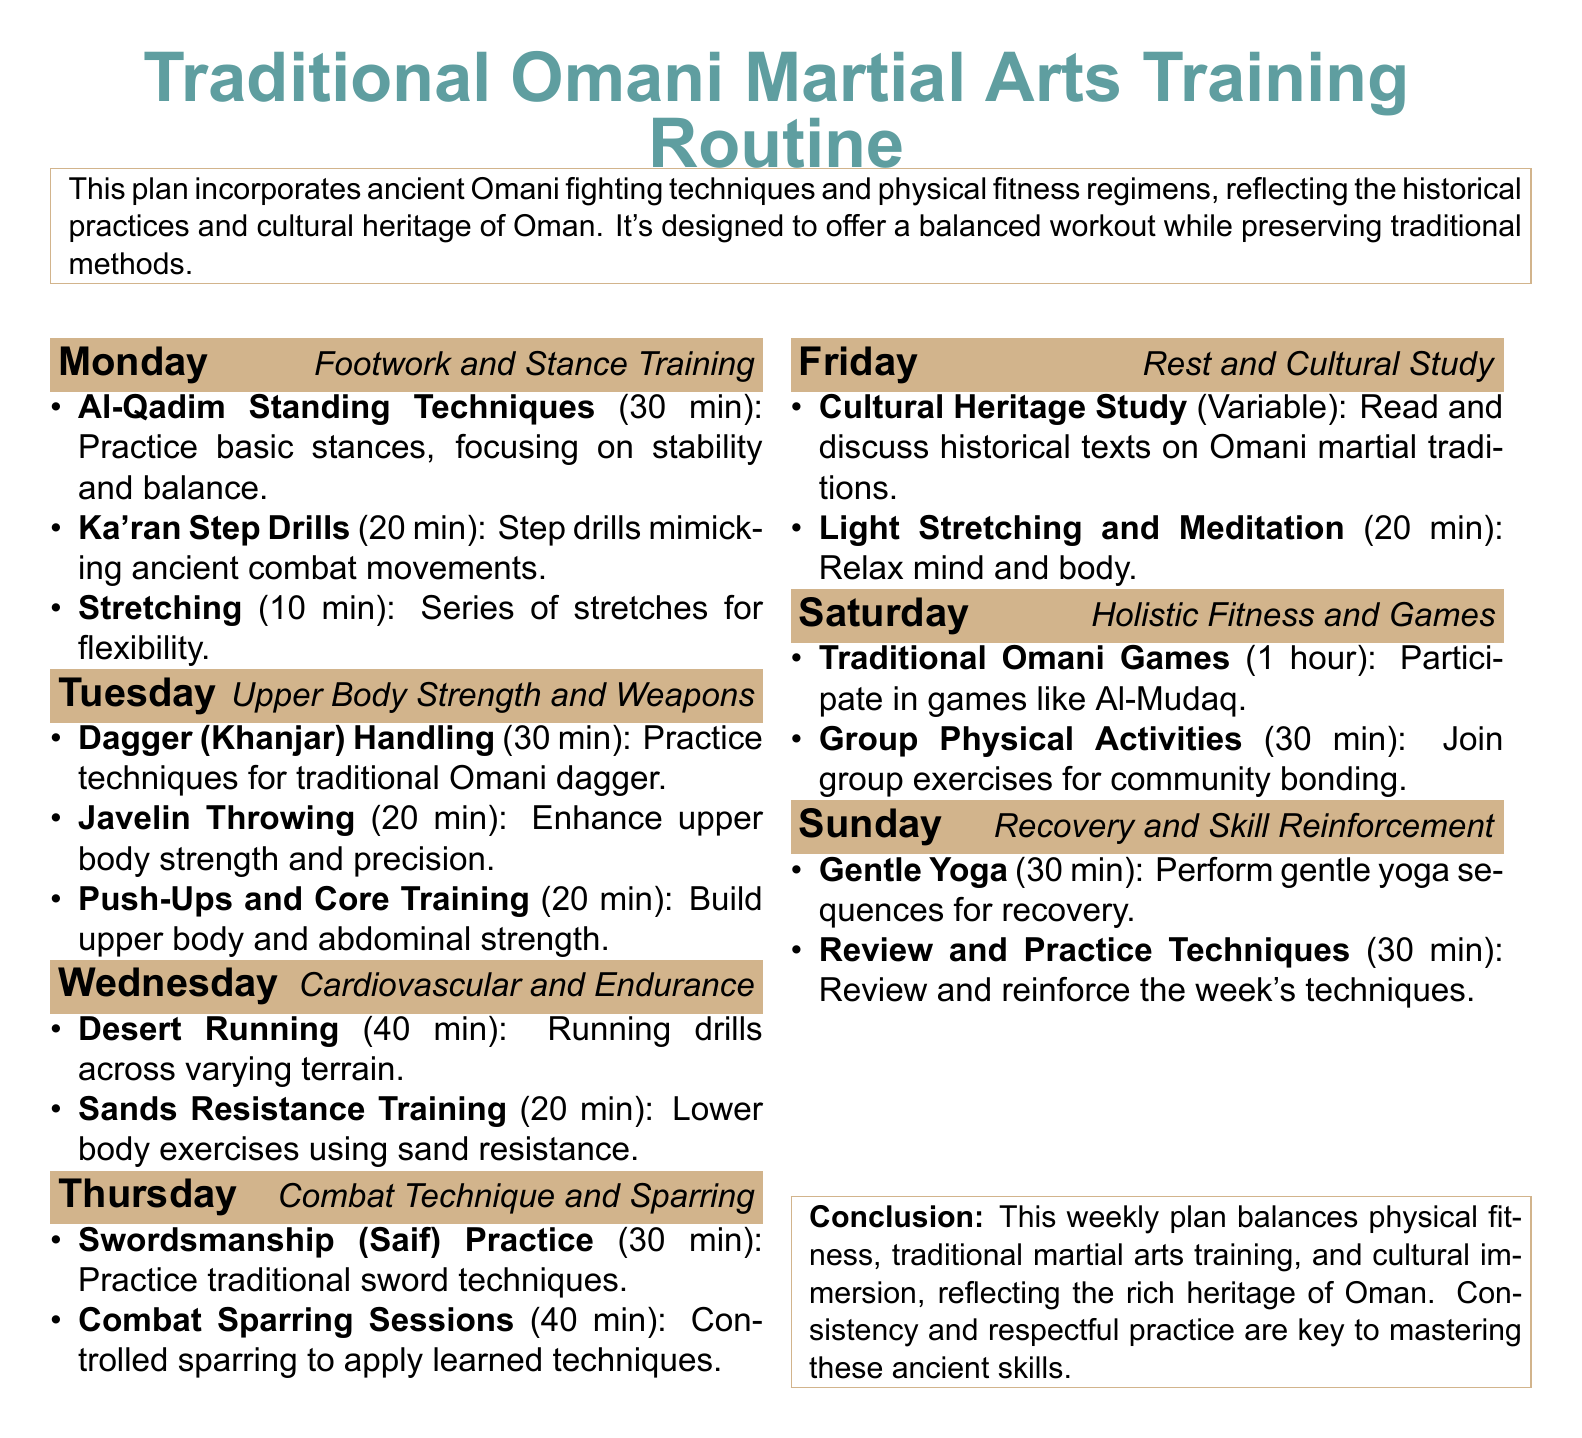What is the first day's focus in the training routine? The first day's focus is on footwork and stance training, as mentioned in the document.
Answer: Footwork and Stance Training How long is the combat sparring session on Thursday? The document states that the combat sparring session lasts for 40 minutes.
Answer: 40 min What ancient weapon is practiced on Tuesday? The document identifies the traditional Omani weapon that is practiced as the dagger.
Answer: Dagger (Khanjar) What type of running drills are included on Wednesday? The document mentions that desert running is focused on varying terrain, indicating the type of running drills included.
Answer: Desert Running Which day includes cultural heritage study? The document specifies that cultural heritage study is included on Friday.
Answer: Friday What type of training is combined with traditional games on Saturday? The document indicates that group physical activities are combined with traditional Omani games on Saturday.
Answer: Group Physical Activities How many minutes are dedicated to gentle yoga on Sunday? According to the document, gentle yoga lasts for 30 minutes on Sunday.
Answer: 30 min Which day is designated for rest and relaxation? The document clearly states that Friday is designated for rest and cultural study.
Answer: Friday What is essential for mastering the ancient skills according to the conclusion? The conclusion emphasizes that consistency and respectful practice are key to mastering these skills.
Answer: Consistency and respectful practice 